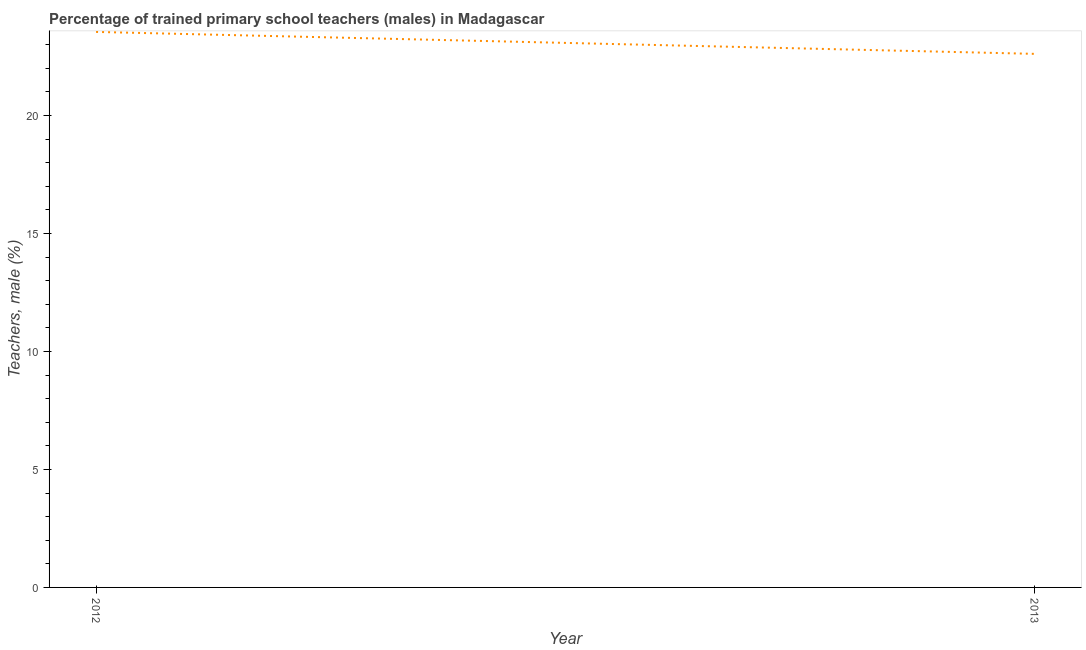What is the percentage of trained male teachers in 2013?
Provide a short and direct response. 22.62. Across all years, what is the maximum percentage of trained male teachers?
Offer a terse response. 23.55. Across all years, what is the minimum percentage of trained male teachers?
Make the answer very short. 22.62. What is the sum of the percentage of trained male teachers?
Your answer should be compact. 46.16. What is the difference between the percentage of trained male teachers in 2012 and 2013?
Your answer should be compact. 0.93. What is the average percentage of trained male teachers per year?
Your answer should be compact. 23.08. What is the median percentage of trained male teachers?
Provide a short and direct response. 23.08. What is the ratio of the percentage of trained male teachers in 2012 to that in 2013?
Ensure brevity in your answer.  1.04. Is the percentage of trained male teachers in 2012 less than that in 2013?
Offer a very short reply. No. In how many years, is the percentage of trained male teachers greater than the average percentage of trained male teachers taken over all years?
Offer a very short reply. 1. How many years are there in the graph?
Offer a very short reply. 2. What is the difference between two consecutive major ticks on the Y-axis?
Your answer should be compact. 5. Does the graph contain any zero values?
Provide a succinct answer. No. Does the graph contain grids?
Provide a succinct answer. No. What is the title of the graph?
Provide a succinct answer. Percentage of trained primary school teachers (males) in Madagascar. What is the label or title of the Y-axis?
Provide a succinct answer. Teachers, male (%). What is the Teachers, male (%) in 2012?
Make the answer very short. 23.55. What is the Teachers, male (%) in 2013?
Make the answer very short. 22.62. What is the difference between the Teachers, male (%) in 2012 and 2013?
Keep it short and to the point. 0.93. What is the ratio of the Teachers, male (%) in 2012 to that in 2013?
Give a very brief answer. 1.04. 